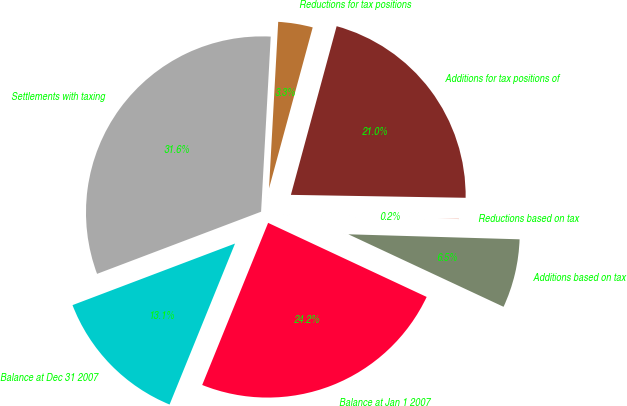Convert chart. <chart><loc_0><loc_0><loc_500><loc_500><pie_chart><fcel>Balance at Jan 1 2007<fcel>Additions based on tax<fcel>Reductions based on tax<fcel>Additions for tax positions of<fcel>Reductions for tax positions<fcel>Settlements with taxing<fcel>Balance at Dec 31 2007<nl><fcel>24.19%<fcel>6.49%<fcel>0.2%<fcel>21.05%<fcel>3.34%<fcel>31.64%<fcel>13.09%<nl></chart> 